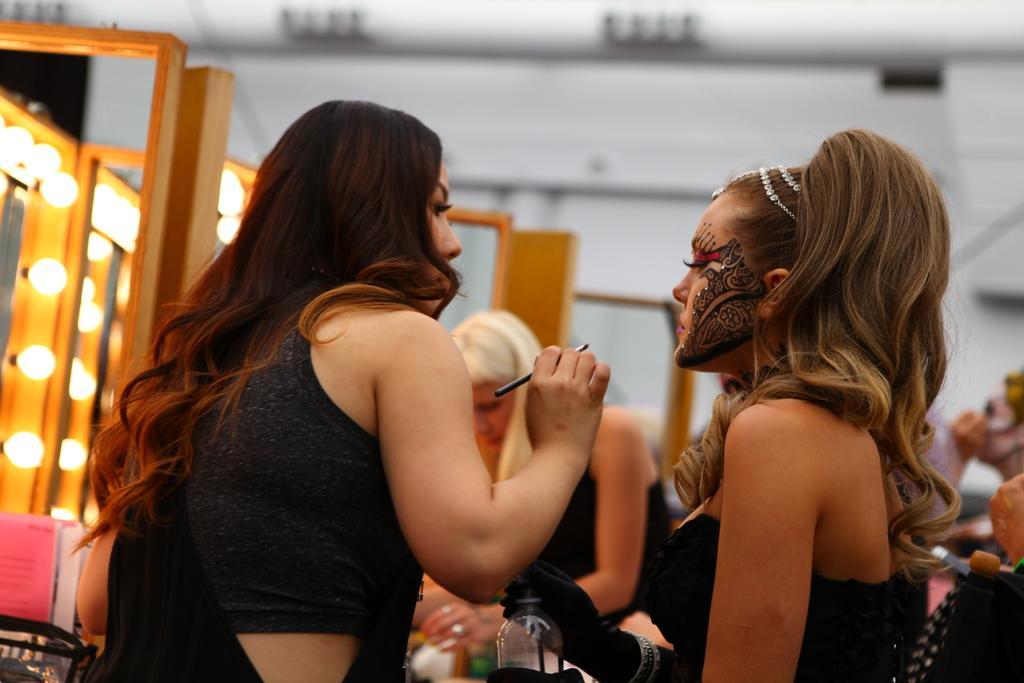Could you give a brief overview of what you see in this image? In this picture we can see some people, bottle, lights and some objects and in the background it is blurry. 